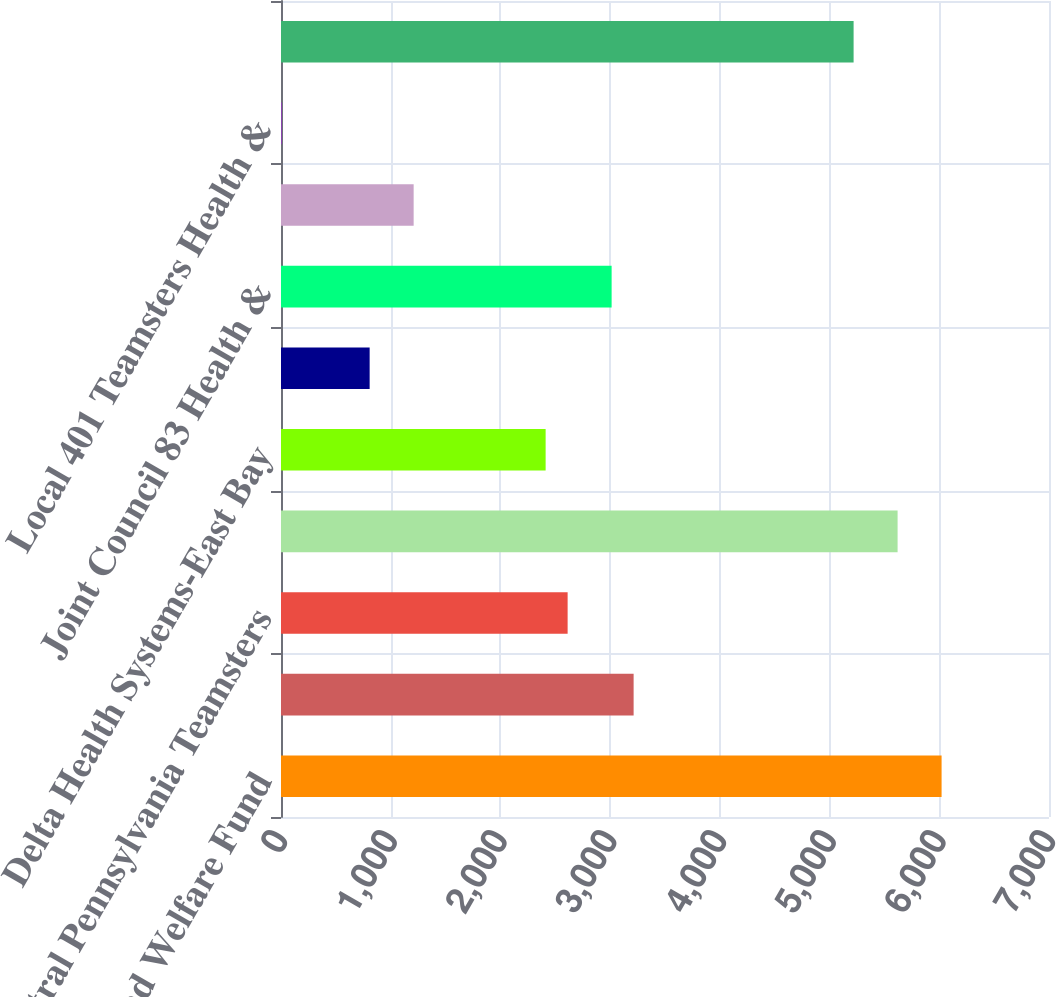Convert chart. <chart><loc_0><loc_0><loc_500><loc_500><bar_chart><fcel>Health and Welfare Fund<fcel>Bay Area Delivery Drivers<fcel>Central Pennsylvania Teamsters<fcel>Central States South East &<fcel>Delta Health Systems-East Bay<fcel>Employer-Teamster Local Nos<fcel>Joint Council 83 Health &<fcel>Local 191 Teamsters Health<fcel>Local 401 Teamsters Health &<fcel>Local 804 Welfare Trust Fund<nl><fcel>6021<fcel>3214<fcel>2612.5<fcel>5620<fcel>2412<fcel>808<fcel>3013.5<fcel>1209<fcel>6<fcel>5219<nl></chart> 